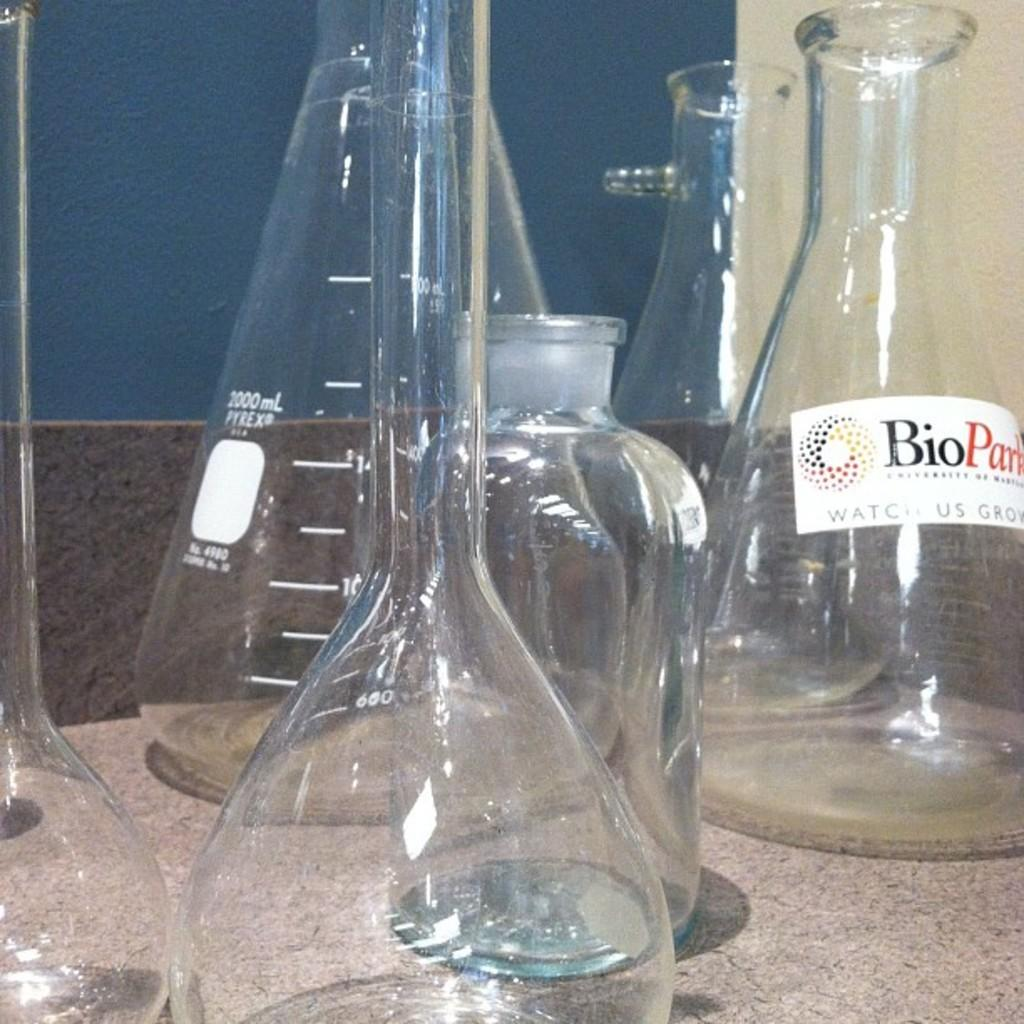<image>
Share a concise interpretation of the image provided. A bunch of science beakers with one having a white label from Bio 